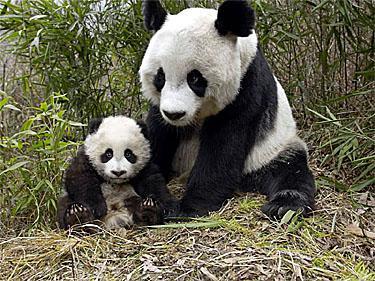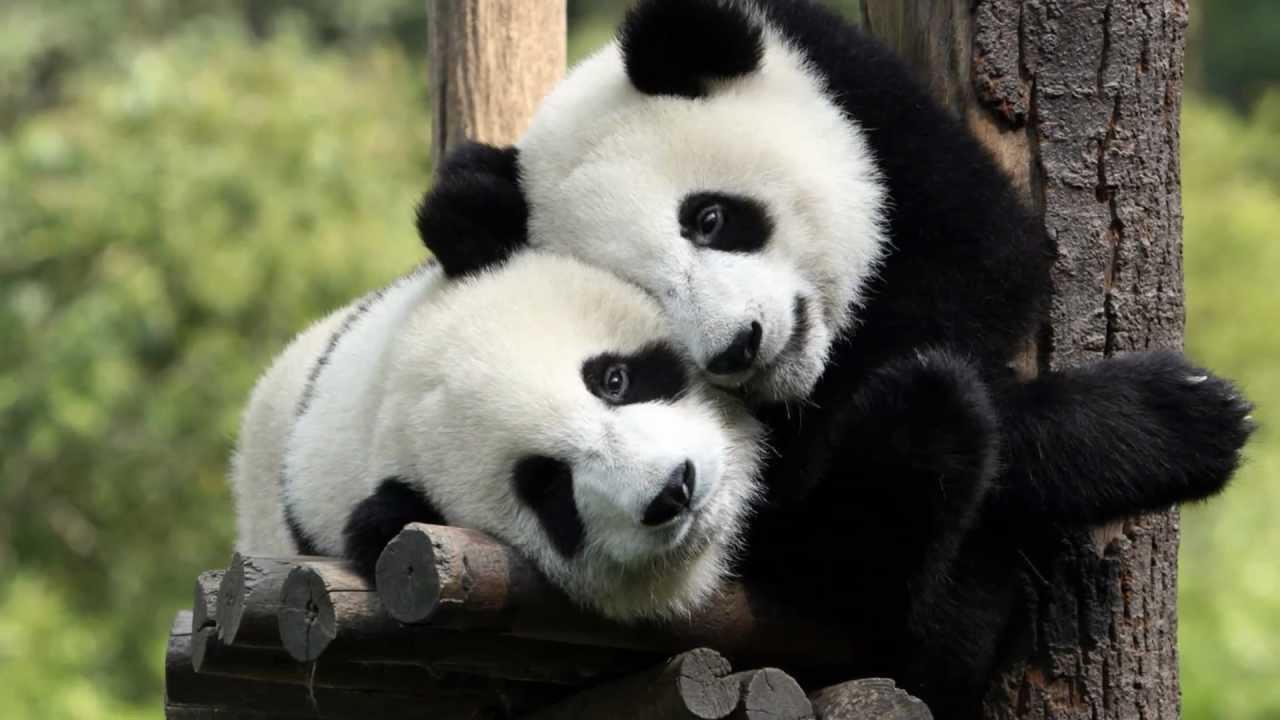The first image is the image on the left, the second image is the image on the right. Given the left and right images, does the statement "An image shows a panda munching on a branch." hold true? Answer yes or no. No. 